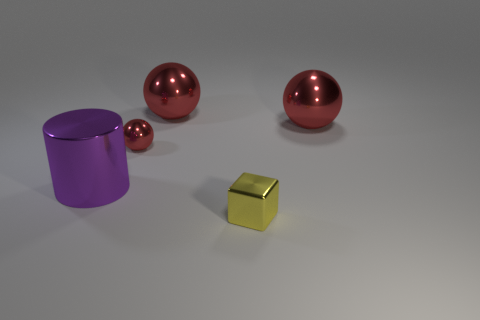What is the shape of the tiny thing that is in front of the small metal thing that is behind the large purple metallic object?
Ensure brevity in your answer.  Cube. What number of other things are there of the same material as the yellow thing
Your answer should be compact. 4. Are there more green things than large purple metal things?
Your answer should be very brief. No. There is a metallic sphere on the right side of the tiny metal thing that is in front of the tiny thing behind the large purple cylinder; what is its size?
Make the answer very short. Large. Does the yellow thing have the same size as the thing that is to the left of the tiny red shiny object?
Provide a succinct answer. No. Is the number of large shiny things that are left of the tiny yellow object less than the number of red rubber objects?
Provide a succinct answer. No. How many small metal spheres have the same color as the metallic block?
Your answer should be compact. 0. Is the number of small red objects less than the number of red metallic things?
Offer a very short reply. Yes. How many other things are the same size as the shiny block?
Your answer should be very brief. 1. There is a thing on the left side of the small shiny object that is behind the cylinder; what color is it?
Offer a very short reply. Purple. 